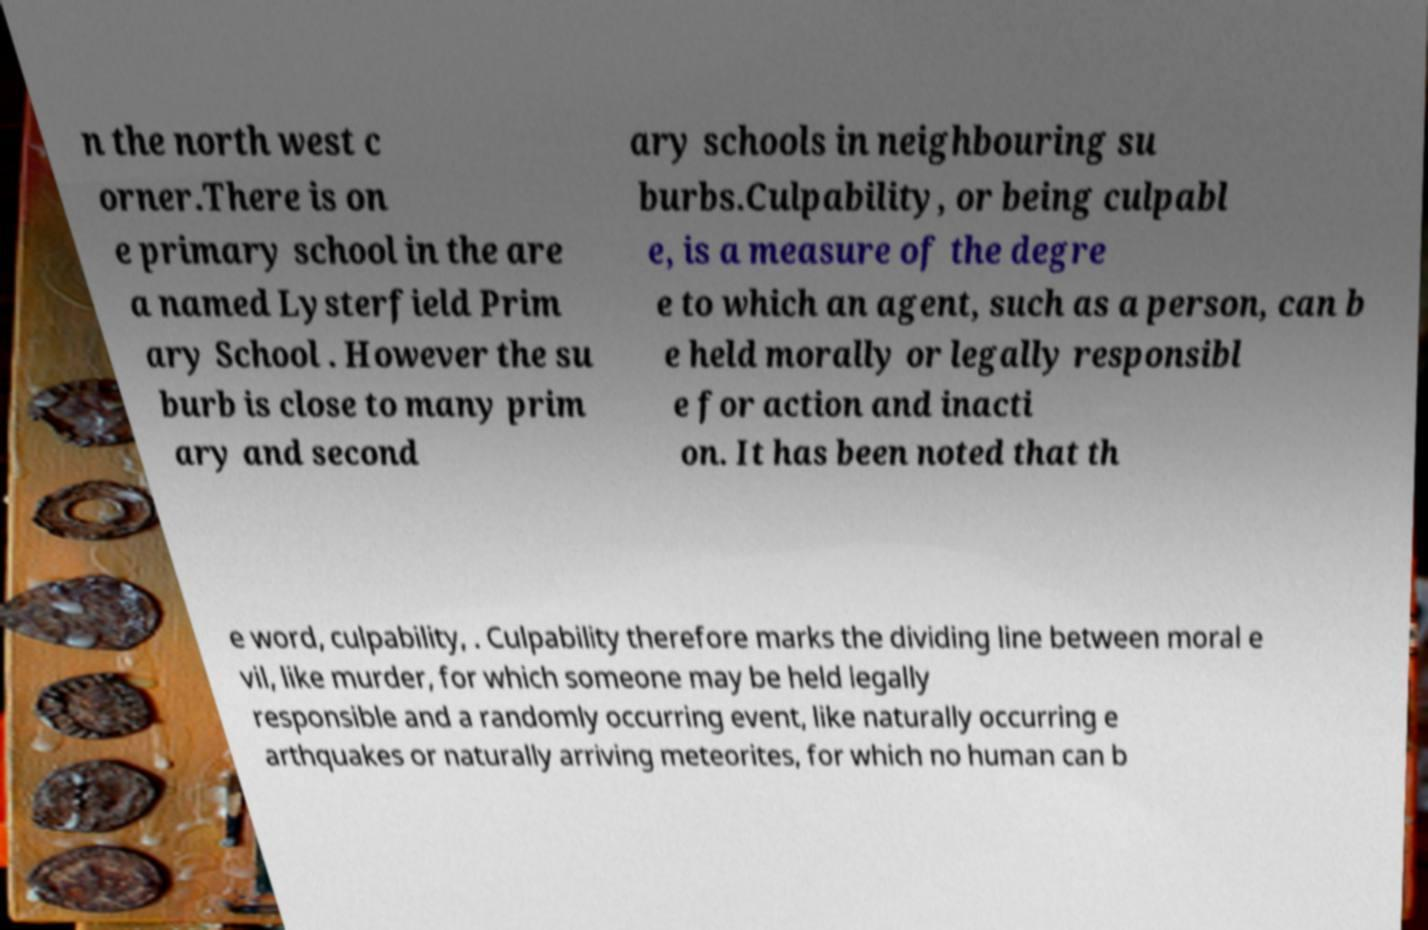Can you accurately transcribe the text from the provided image for me? n the north west c orner.There is on e primary school in the are a named Lysterfield Prim ary School . However the su burb is close to many prim ary and second ary schools in neighbouring su burbs.Culpability, or being culpabl e, is a measure of the degre e to which an agent, such as a person, can b e held morally or legally responsibl e for action and inacti on. It has been noted that th e word, culpability, . Culpability therefore marks the dividing line between moral e vil, like murder, for which someone may be held legally responsible and a randomly occurring event, like naturally occurring e arthquakes or naturally arriving meteorites, for which no human can b 